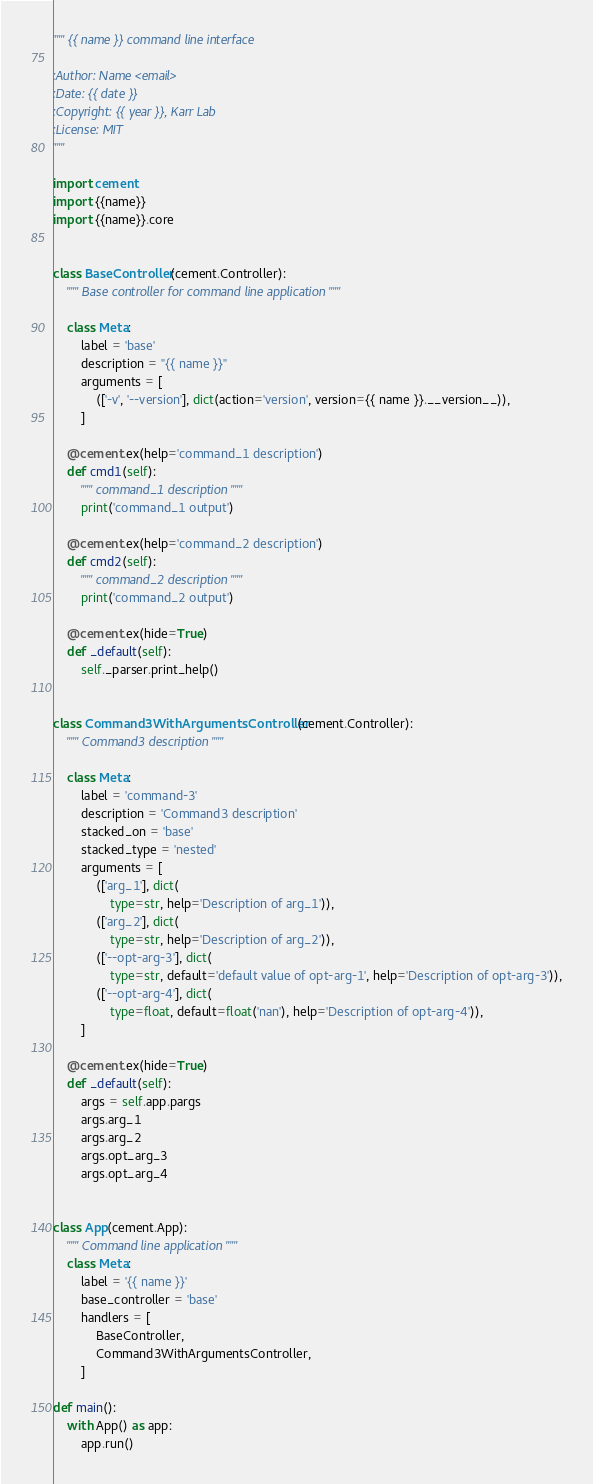Convert code to text. <code><loc_0><loc_0><loc_500><loc_500><_Python_>""" {{ name }} command line interface

:Author: Name <email>
:Date: {{ date }}
:Copyright: {{ year }}, Karr Lab
:License: MIT
"""

import cement
import {{name}}
import {{name}}.core


class BaseController(cement.Controller):
    """ Base controller for command line application """

    class Meta:
        label = 'base'
        description = "{{ name }}"
        arguments = [
            (['-v', '--version'], dict(action='version', version={{ name }}.__version__)),
        ]

    @cement.ex(help='command_1 description')
    def cmd1(self):
        """ command_1 description """
        print('command_1 output')

    @cement.ex(help='command_2 description')
    def cmd2(self):
        """ command_2 description """
        print('command_2 output')

    @cement.ex(hide=True)
    def _default(self):
        self._parser.print_help()


class Command3WithArgumentsController(cement.Controller):
    """ Command3 description """

    class Meta:
        label = 'command-3'
        description = 'Command3 description'
        stacked_on = 'base'
        stacked_type = 'nested'
        arguments = [
            (['arg_1'], dict(
                type=str, help='Description of arg_1')),
            (['arg_2'], dict(
                type=str, help='Description of arg_2')),
            (['--opt-arg-3'], dict(
                type=str, default='default value of opt-arg-1', help='Description of opt-arg-3')),
            (['--opt-arg-4'], dict(
                type=float, default=float('nan'), help='Description of opt-arg-4')),
        ]

    @cement.ex(hide=True)
    def _default(self):
        args = self.app.pargs
        args.arg_1
        args.arg_2
        args.opt_arg_3
        args.opt_arg_4


class App(cement.App):
    """ Command line application """
    class Meta:
        label = '{{ name }}'
        base_controller = 'base'
        handlers = [
            BaseController,
            Command3WithArgumentsController,
        ]

def main():
    with App() as app:
        app.run()
</code> 